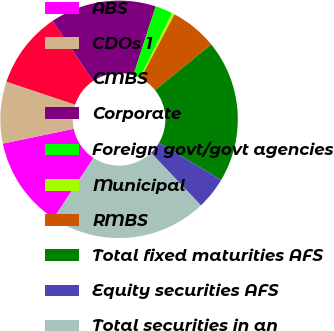Convert chart to OTSL. <chart><loc_0><loc_0><loc_500><loc_500><pie_chart><fcel>ABS<fcel>CDOs 1<fcel>CMBS<fcel>Corporate<fcel>Foreign govt/govt agencies<fcel>Municipal<fcel>RMBS<fcel>Total fixed maturities AFS<fcel>Equity securities AFS<fcel>Total securities in an<nl><fcel>12.43%<fcel>8.41%<fcel>10.42%<fcel>14.44%<fcel>2.38%<fcel>0.37%<fcel>6.4%<fcel>19.38%<fcel>4.39%<fcel>21.39%<nl></chart> 